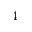<formula> <loc_0><loc_0><loc_500><loc_500>4</formula> 